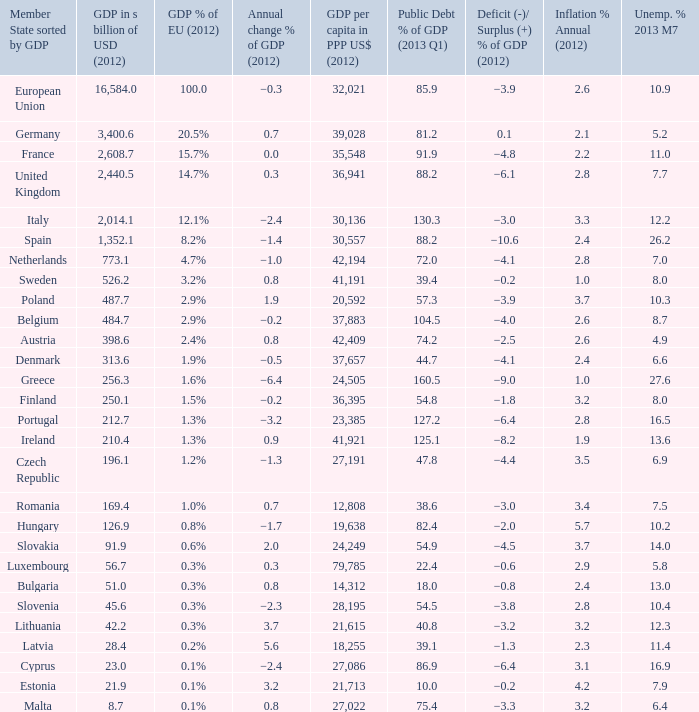What was the eu gdp percentage in 2012 for a country that had a gdp of 256.3 billion usd in the same year? 1.6%. 